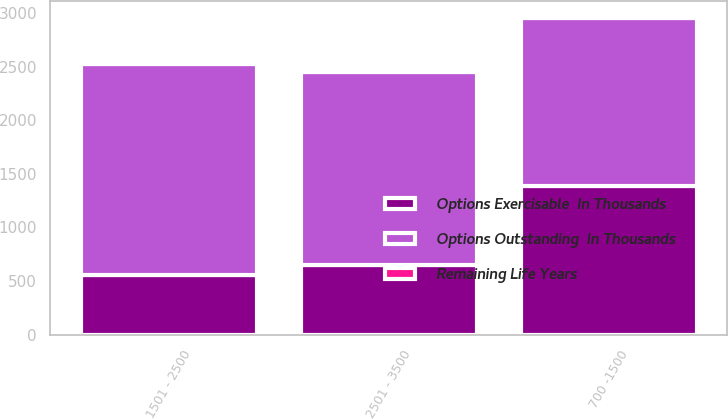Convert chart. <chart><loc_0><loc_0><loc_500><loc_500><stacked_bar_chart><ecel><fcel>700 -1500<fcel>1501 - 2500<fcel>2501 - 3500<nl><fcel>Options Outstanding  In Thousands<fcel>1566<fcel>1970<fcel>1803<nl><fcel>Remaining Life Years<fcel>4.98<fcel>7.99<fcel>7.97<nl><fcel>Options Exercisable  In Thousands<fcel>1390<fcel>553<fcel>648<nl></chart> 